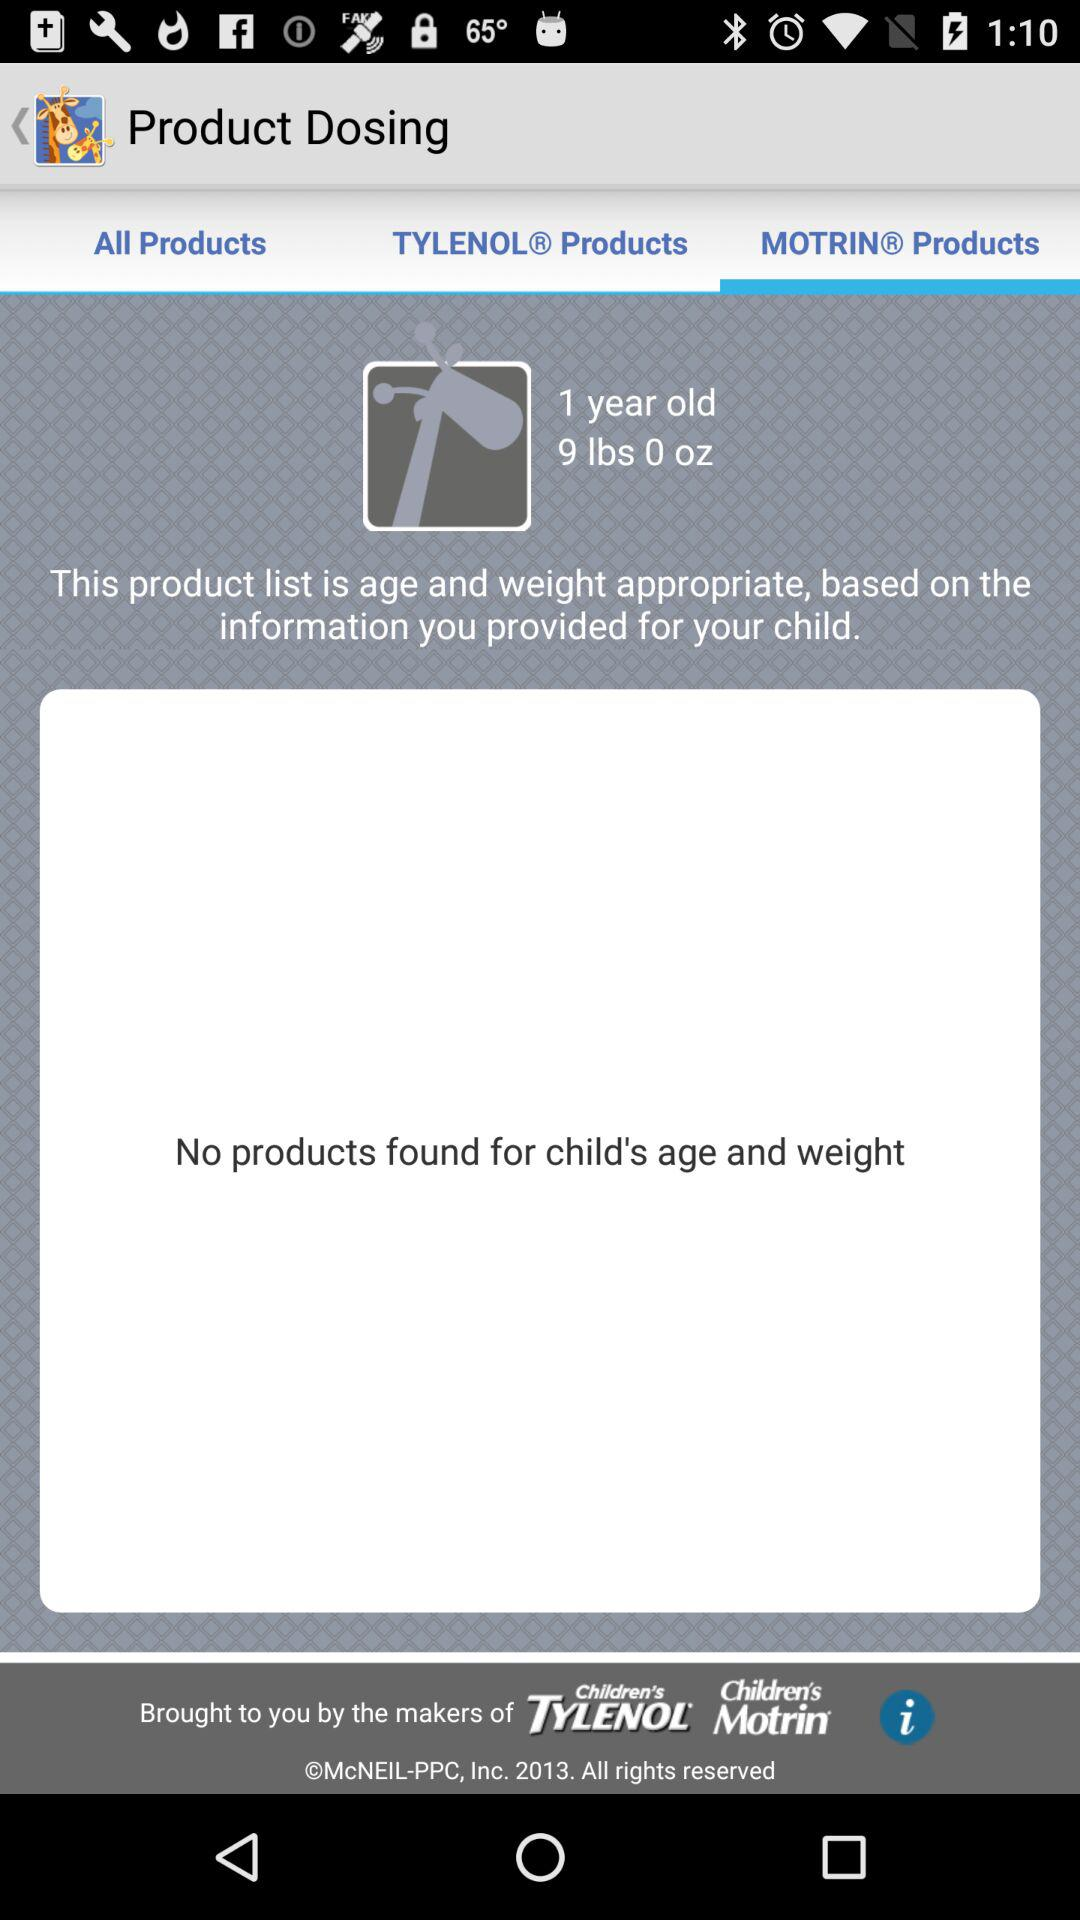Which tab is selected? The tab "MOTRIN® Products" is selected. 